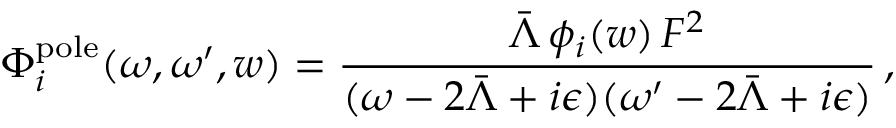Convert formula to latex. <formula><loc_0><loc_0><loc_500><loc_500>\Phi _ { i } ^ { p o l e } ( \omega , \omega ^ { \prime } , w ) = \frac { \bar { \Lambda } \, \phi _ { i } ( w ) \, F ^ { 2 } } { ( \omega - 2 \bar { \Lambda } + i \epsilon ) ( \omega ^ { \prime } - 2 \bar { \Lambda } + i \epsilon ) } \, ,</formula> 